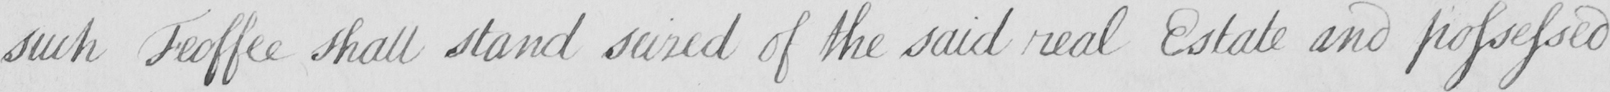Can you tell me what this handwritten text says? such Feoffee shall stand seized of the said real Estate and possessed 